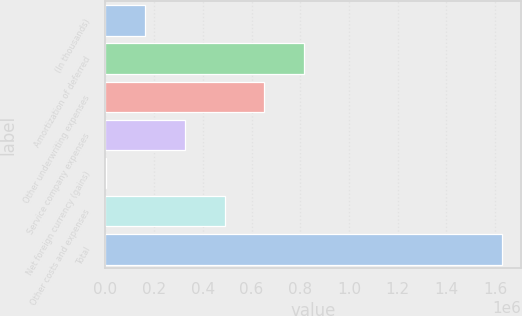<chart> <loc_0><loc_0><loc_500><loc_500><bar_chart><fcel>(In thousands)<fcel>Amortization of deferred<fcel>Other underwriting expenses<fcel>Service company expenses<fcel>Net foreign currency (gains)<fcel>Other costs and expenses<fcel>Total<nl><fcel>164348<fcel>815475<fcel>653011<fcel>326812<fcel>1884<fcel>489277<fcel>1.62653e+06<nl></chart> 